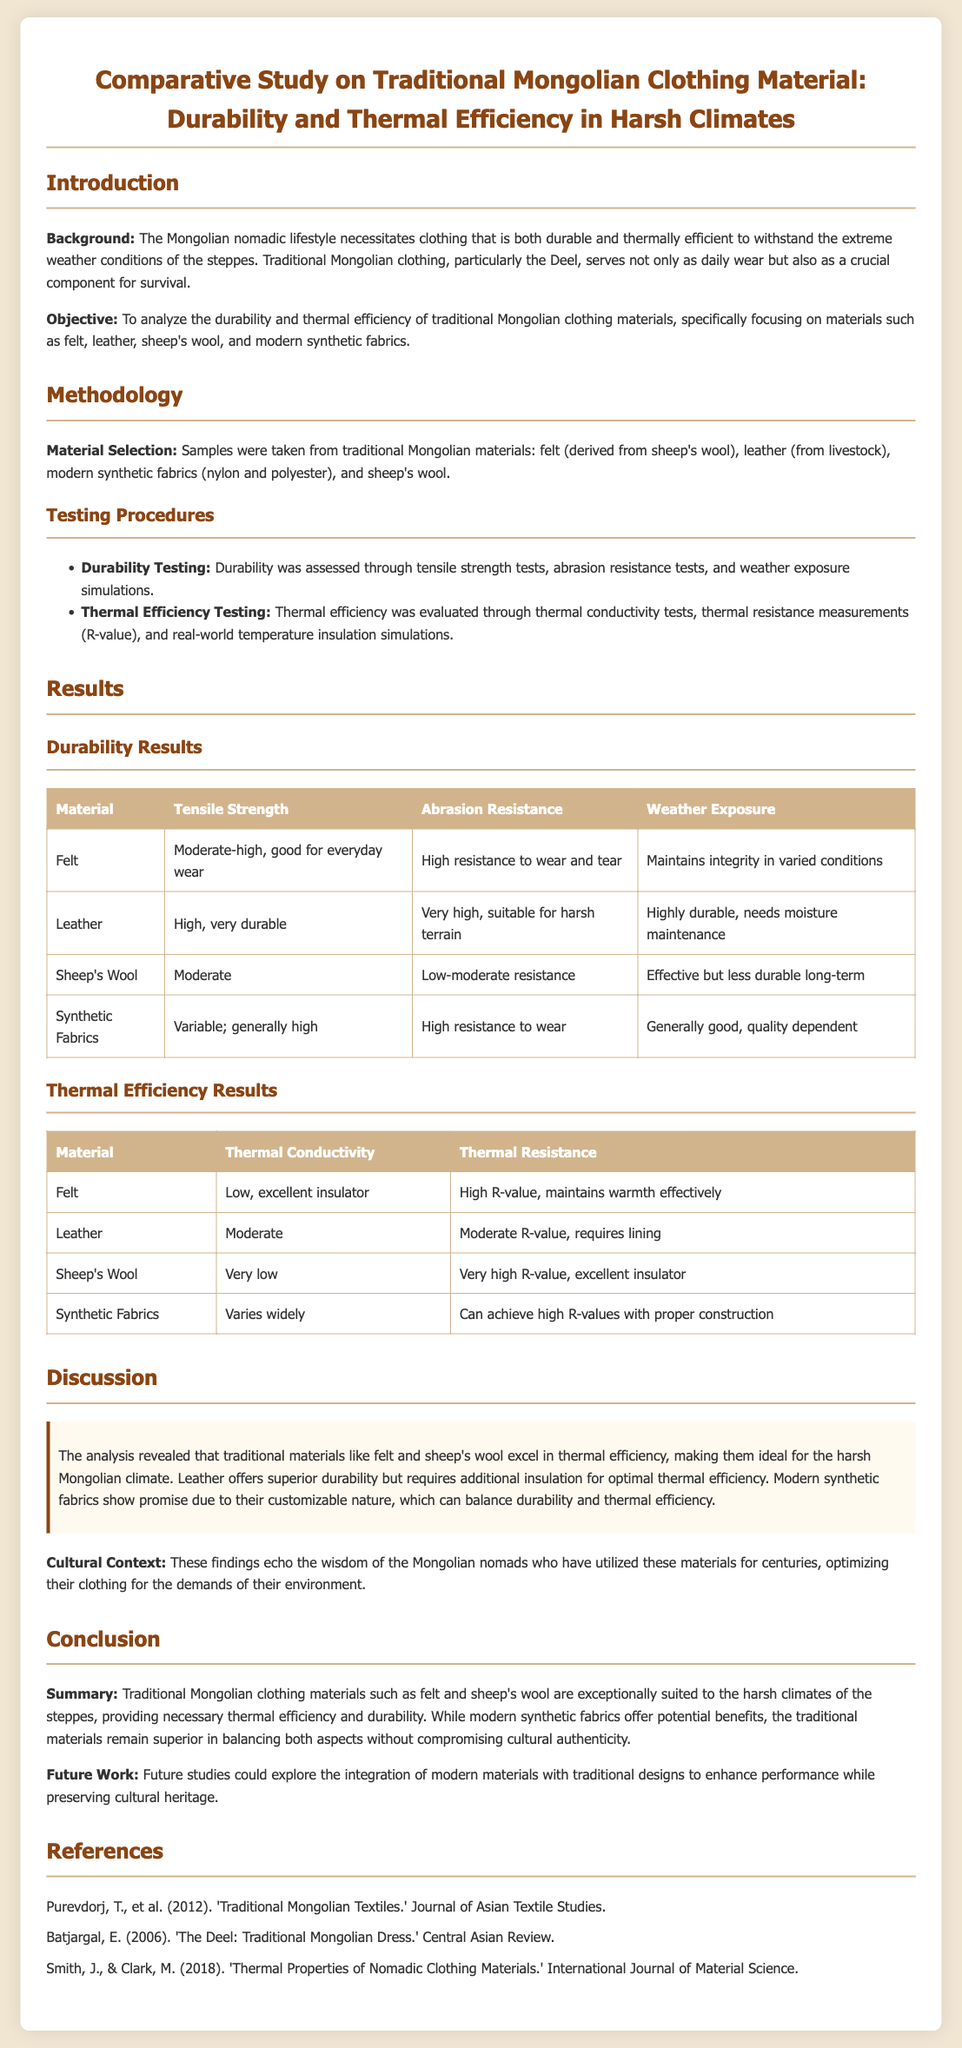What is the main objective of the study? The objective is to analyze the durability and thermal efficiency of traditional Mongolian clothing materials.
Answer: To analyze durability and thermal efficiency What traditional material showed the highest thermal insulation capability? Sheep's wool was noted for its very high R-value, indicating excellent insulation.
Answer: Sheep's Wool Which testing method was used to assess durability? Durability was assessed through tensile strength tests, abrasion resistance tests, and weather exposure simulations.
Answer: Tensile strength tests What was the result of the abrasion resistance test for leather? Leather had very high abrasion resistance, suitable for harsh terrain.
Answer: Very high What conclusion is drawn about modern synthetic fabrics? Modern synthetic fabrics can achieve high R-values with proper construction, showing promise in performance.
Answer: Show promise How is the cultural significance of the clothing materials reflected? The findings echo the wisdom of the Mongolian nomads who have utilized these materials for centuries.
Answer: Wisdom of nomads What was the thermal resistance result for felt? Felt has a high R-value, maintaining warmth effectively.
Answer: High R-value What does R-value indicate in the context of this study? R-value is a measure of thermal resistance, indicating effectiveness at insulating against heat transfer.
Answer: Thermal resistance 